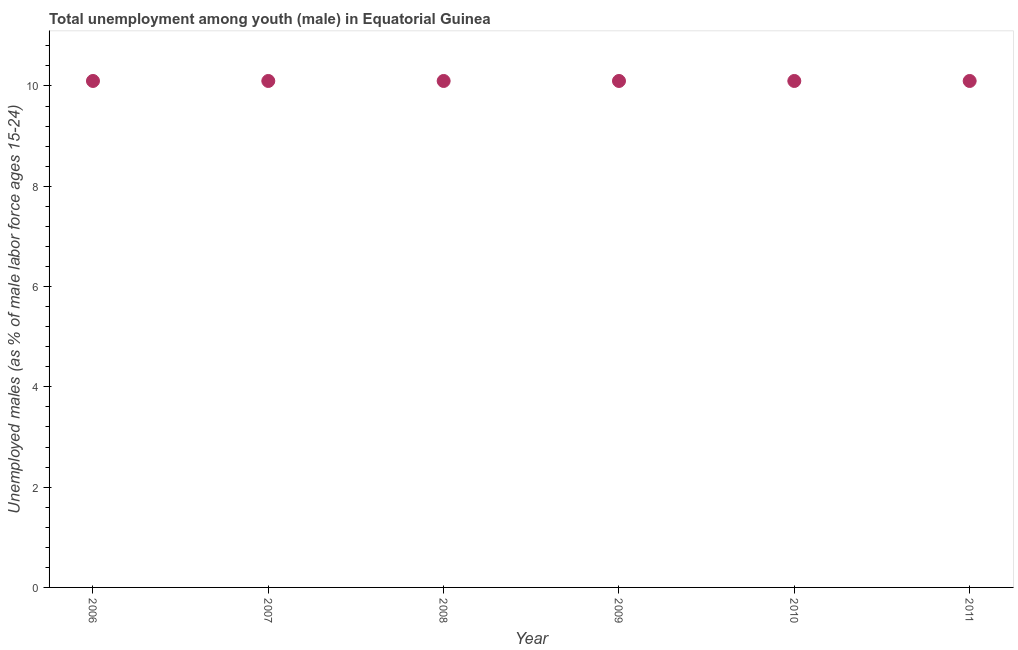What is the unemployed male youth population in 2011?
Your answer should be very brief. 10.1. Across all years, what is the maximum unemployed male youth population?
Keep it short and to the point. 10.1. Across all years, what is the minimum unemployed male youth population?
Ensure brevity in your answer.  10.1. In which year was the unemployed male youth population minimum?
Ensure brevity in your answer.  2006. What is the sum of the unemployed male youth population?
Your answer should be very brief. 60.6. What is the difference between the unemployed male youth population in 2008 and 2011?
Your answer should be very brief. 0. What is the average unemployed male youth population per year?
Your answer should be compact. 10.1. What is the median unemployed male youth population?
Offer a terse response. 10.1. In how many years, is the unemployed male youth population greater than 9.2 %?
Ensure brevity in your answer.  6. Do a majority of the years between 2010 and 2008 (inclusive) have unemployed male youth population greater than 3.6 %?
Ensure brevity in your answer.  No. What is the ratio of the unemployed male youth population in 2006 to that in 2007?
Your answer should be very brief. 1. Is the difference between the unemployed male youth population in 2010 and 2011 greater than the difference between any two years?
Offer a terse response. Yes. What is the difference between the highest and the lowest unemployed male youth population?
Your answer should be compact. 0. Does the unemployed male youth population monotonically increase over the years?
Provide a succinct answer. No. How many dotlines are there?
Offer a very short reply. 1. Are the values on the major ticks of Y-axis written in scientific E-notation?
Ensure brevity in your answer.  No. Does the graph contain any zero values?
Offer a terse response. No. Does the graph contain grids?
Offer a terse response. No. What is the title of the graph?
Offer a terse response. Total unemployment among youth (male) in Equatorial Guinea. What is the label or title of the Y-axis?
Your response must be concise. Unemployed males (as % of male labor force ages 15-24). What is the Unemployed males (as % of male labor force ages 15-24) in 2006?
Offer a terse response. 10.1. What is the Unemployed males (as % of male labor force ages 15-24) in 2007?
Your response must be concise. 10.1. What is the Unemployed males (as % of male labor force ages 15-24) in 2008?
Offer a terse response. 10.1. What is the Unemployed males (as % of male labor force ages 15-24) in 2009?
Make the answer very short. 10.1. What is the Unemployed males (as % of male labor force ages 15-24) in 2010?
Your answer should be compact. 10.1. What is the Unemployed males (as % of male labor force ages 15-24) in 2011?
Give a very brief answer. 10.1. What is the difference between the Unemployed males (as % of male labor force ages 15-24) in 2006 and 2007?
Your response must be concise. 0. What is the difference between the Unemployed males (as % of male labor force ages 15-24) in 2006 and 2010?
Your response must be concise. 0. What is the difference between the Unemployed males (as % of male labor force ages 15-24) in 2007 and 2008?
Your response must be concise. 0. What is the difference between the Unemployed males (as % of male labor force ages 15-24) in 2008 and 2009?
Give a very brief answer. 0. What is the difference between the Unemployed males (as % of male labor force ages 15-24) in 2009 and 2011?
Provide a succinct answer. 0. What is the ratio of the Unemployed males (as % of male labor force ages 15-24) in 2006 to that in 2008?
Your answer should be very brief. 1. What is the ratio of the Unemployed males (as % of male labor force ages 15-24) in 2006 to that in 2011?
Give a very brief answer. 1. What is the ratio of the Unemployed males (as % of male labor force ages 15-24) in 2007 to that in 2008?
Your answer should be compact. 1. What is the ratio of the Unemployed males (as % of male labor force ages 15-24) in 2007 to that in 2009?
Your answer should be very brief. 1. What is the ratio of the Unemployed males (as % of male labor force ages 15-24) in 2007 to that in 2010?
Offer a very short reply. 1. What is the ratio of the Unemployed males (as % of male labor force ages 15-24) in 2008 to that in 2010?
Ensure brevity in your answer.  1. What is the ratio of the Unemployed males (as % of male labor force ages 15-24) in 2009 to that in 2010?
Provide a short and direct response. 1. What is the ratio of the Unemployed males (as % of male labor force ages 15-24) in 2010 to that in 2011?
Offer a terse response. 1. 